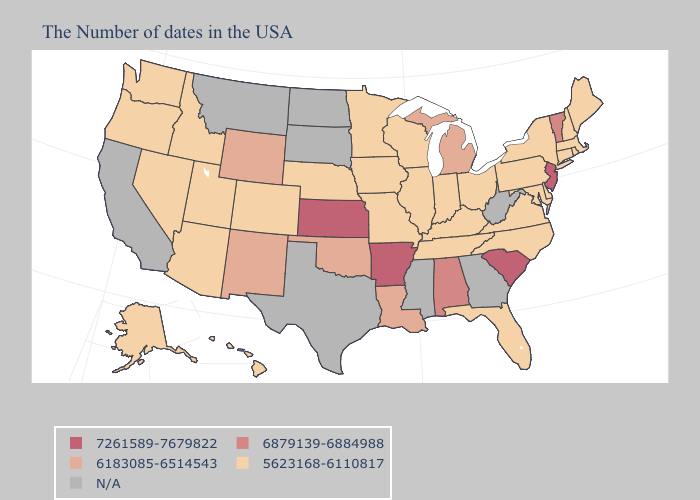Is the legend a continuous bar?
Be succinct. No. Does the map have missing data?
Short answer required. Yes. Name the states that have a value in the range 6879139-6884988?
Write a very short answer. Vermont, Alabama. Name the states that have a value in the range N/A?
Be succinct. West Virginia, Georgia, Mississippi, Texas, South Dakota, North Dakota, Montana, California. What is the value of Utah?
Concise answer only. 5623168-6110817. Name the states that have a value in the range 6879139-6884988?
Give a very brief answer. Vermont, Alabama. Which states have the lowest value in the USA?
Concise answer only. Maine, Massachusetts, Rhode Island, New Hampshire, Connecticut, New York, Delaware, Maryland, Pennsylvania, Virginia, North Carolina, Ohio, Florida, Kentucky, Indiana, Tennessee, Wisconsin, Illinois, Missouri, Minnesota, Iowa, Nebraska, Colorado, Utah, Arizona, Idaho, Nevada, Washington, Oregon, Alaska, Hawaii. Name the states that have a value in the range 7261589-7679822?
Concise answer only. New Jersey, South Carolina, Arkansas, Kansas. Does Delaware have the lowest value in the USA?
Be succinct. Yes. What is the value of Tennessee?
Quick response, please. 5623168-6110817. How many symbols are there in the legend?
Give a very brief answer. 5. Which states hav the highest value in the Northeast?
Answer briefly. New Jersey. Does South Carolina have the highest value in the USA?
Quick response, please. Yes. 